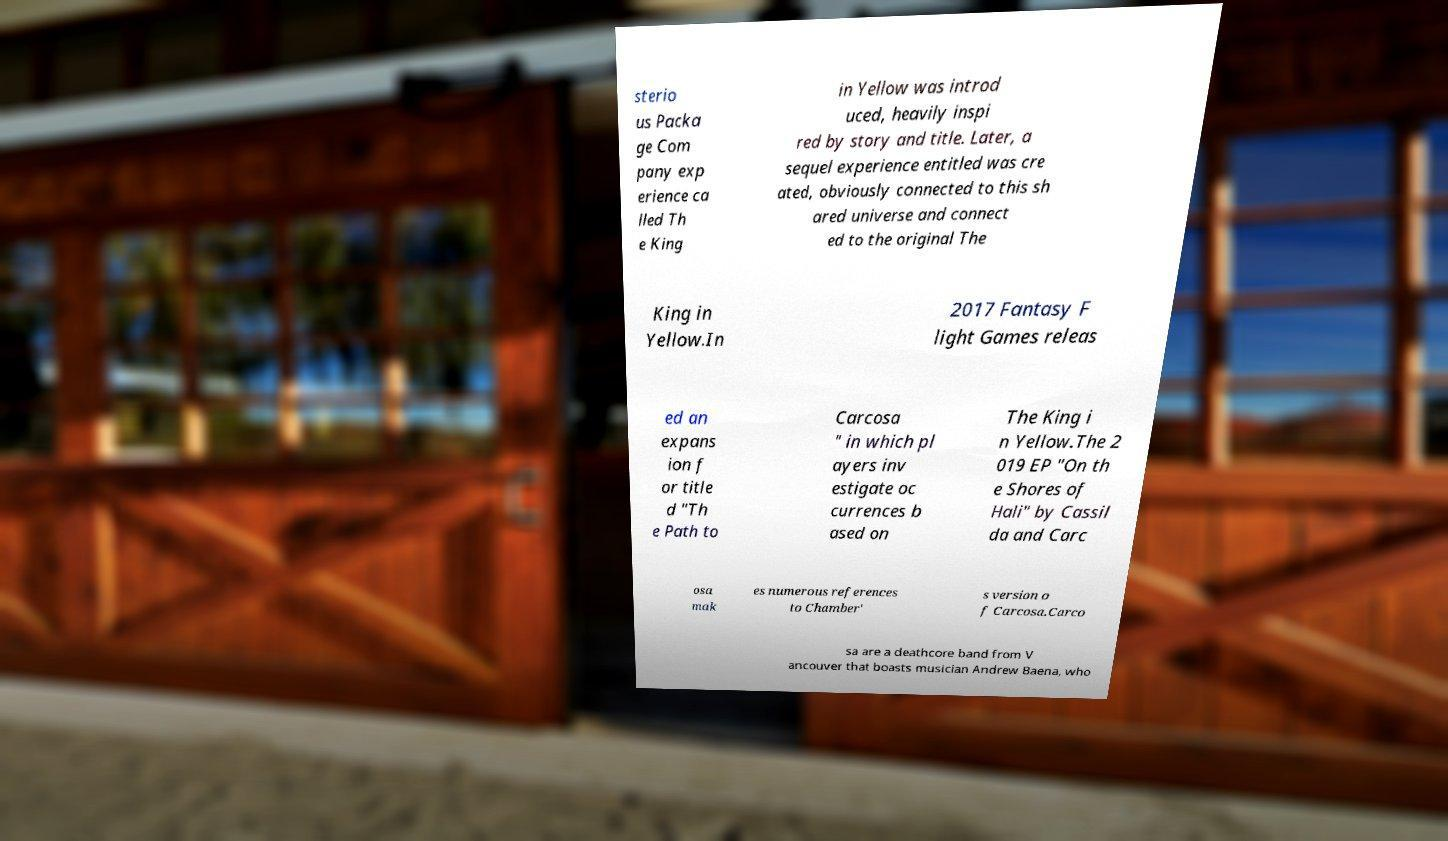Please identify and transcribe the text found in this image. sterio us Packa ge Com pany exp erience ca lled Th e King in Yellow was introd uced, heavily inspi red by story and title. Later, a sequel experience entitled was cre ated, obviously connected to this sh ared universe and connect ed to the original The King in Yellow.In 2017 Fantasy F light Games releas ed an expans ion f or title d "Th e Path to Carcosa " in which pl ayers inv estigate oc currences b ased on The King i n Yellow.The 2 019 EP "On th e Shores of Hali" by Cassil da and Carc osa mak es numerous references to Chamber' s version o f Carcosa.Carco sa are a deathcore band from V ancouver that boasts musician Andrew Baena, who 